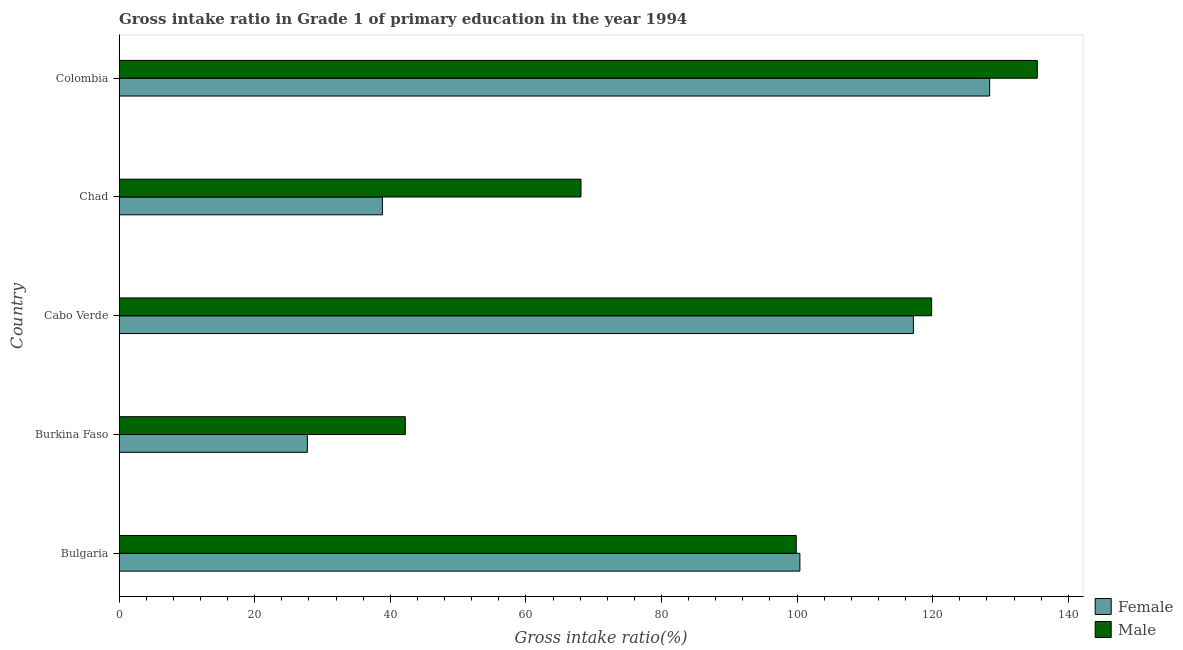How many different coloured bars are there?
Provide a short and direct response. 2. How many groups of bars are there?
Offer a very short reply. 5. What is the label of the 5th group of bars from the top?
Your answer should be compact. Bulgaria. What is the gross intake ratio(male) in Cabo Verde?
Keep it short and to the point. 119.84. Across all countries, what is the maximum gross intake ratio(female)?
Your answer should be compact. 128.4. Across all countries, what is the minimum gross intake ratio(male)?
Offer a very short reply. 42.22. In which country was the gross intake ratio(male) maximum?
Your response must be concise. Colombia. In which country was the gross intake ratio(female) minimum?
Ensure brevity in your answer.  Burkina Faso. What is the total gross intake ratio(female) in the graph?
Keep it short and to the point. 412.57. What is the difference between the gross intake ratio(male) in Chad and that in Colombia?
Offer a terse response. -67.3. What is the difference between the gross intake ratio(male) in Bulgaria and the gross intake ratio(female) in Chad?
Provide a short and direct response. 61.03. What is the average gross intake ratio(female) per country?
Keep it short and to the point. 82.51. What is the difference between the gross intake ratio(male) and gross intake ratio(female) in Burkina Faso?
Your response must be concise. 14.45. What is the ratio of the gross intake ratio(female) in Bulgaria to that in Cabo Verde?
Your response must be concise. 0.86. Is the difference between the gross intake ratio(male) in Bulgaria and Chad greater than the difference between the gross intake ratio(female) in Bulgaria and Chad?
Provide a short and direct response. No. What is the difference between the highest and the second highest gross intake ratio(male)?
Your answer should be compact. 15.58. What is the difference between the highest and the lowest gross intake ratio(female)?
Offer a very short reply. 100.62. What does the 2nd bar from the top in Cabo Verde represents?
Provide a succinct answer. Female. How many countries are there in the graph?
Offer a terse response. 5. What is the difference between two consecutive major ticks on the X-axis?
Your answer should be very brief. 20. Does the graph contain any zero values?
Your response must be concise. No. Where does the legend appear in the graph?
Your answer should be compact. Bottom right. How are the legend labels stacked?
Give a very brief answer. Vertical. What is the title of the graph?
Keep it short and to the point. Gross intake ratio in Grade 1 of primary education in the year 1994. Does "Females" appear as one of the legend labels in the graph?
Your response must be concise. No. What is the label or title of the X-axis?
Provide a succinct answer. Gross intake ratio(%). What is the label or title of the Y-axis?
Ensure brevity in your answer.  Country. What is the Gross intake ratio(%) in Female in Bulgaria?
Ensure brevity in your answer.  100.41. What is the Gross intake ratio(%) of Male in Bulgaria?
Provide a short and direct response. 99.87. What is the Gross intake ratio(%) of Female in Burkina Faso?
Provide a short and direct response. 27.77. What is the Gross intake ratio(%) in Male in Burkina Faso?
Ensure brevity in your answer.  42.22. What is the Gross intake ratio(%) in Female in Cabo Verde?
Your answer should be compact. 117.15. What is the Gross intake ratio(%) in Male in Cabo Verde?
Your answer should be compact. 119.84. What is the Gross intake ratio(%) of Female in Chad?
Provide a short and direct response. 38.84. What is the Gross intake ratio(%) of Male in Chad?
Make the answer very short. 68.13. What is the Gross intake ratio(%) of Female in Colombia?
Offer a very short reply. 128.4. What is the Gross intake ratio(%) in Male in Colombia?
Offer a very short reply. 135.42. Across all countries, what is the maximum Gross intake ratio(%) of Female?
Give a very brief answer. 128.4. Across all countries, what is the maximum Gross intake ratio(%) of Male?
Make the answer very short. 135.42. Across all countries, what is the minimum Gross intake ratio(%) of Female?
Make the answer very short. 27.77. Across all countries, what is the minimum Gross intake ratio(%) of Male?
Ensure brevity in your answer.  42.22. What is the total Gross intake ratio(%) in Female in the graph?
Give a very brief answer. 412.57. What is the total Gross intake ratio(%) of Male in the graph?
Offer a very short reply. 465.48. What is the difference between the Gross intake ratio(%) in Female in Bulgaria and that in Burkina Faso?
Your answer should be very brief. 72.64. What is the difference between the Gross intake ratio(%) of Male in Bulgaria and that in Burkina Faso?
Provide a succinct answer. 57.65. What is the difference between the Gross intake ratio(%) of Female in Bulgaria and that in Cabo Verde?
Your response must be concise. -16.74. What is the difference between the Gross intake ratio(%) in Male in Bulgaria and that in Cabo Verde?
Provide a short and direct response. -19.97. What is the difference between the Gross intake ratio(%) in Female in Bulgaria and that in Chad?
Offer a terse response. 61.57. What is the difference between the Gross intake ratio(%) of Male in Bulgaria and that in Chad?
Provide a short and direct response. 31.75. What is the difference between the Gross intake ratio(%) in Female in Bulgaria and that in Colombia?
Your answer should be compact. -27.99. What is the difference between the Gross intake ratio(%) of Male in Bulgaria and that in Colombia?
Offer a terse response. -35.55. What is the difference between the Gross intake ratio(%) of Female in Burkina Faso and that in Cabo Verde?
Give a very brief answer. -89.38. What is the difference between the Gross intake ratio(%) in Male in Burkina Faso and that in Cabo Verde?
Your answer should be compact. -77.63. What is the difference between the Gross intake ratio(%) of Female in Burkina Faso and that in Chad?
Offer a very short reply. -11.07. What is the difference between the Gross intake ratio(%) of Male in Burkina Faso and that in Chad?
Provide a short and direct response. -25.91. What is the difference between the Gross intake ratio(%) in Female in Burkina Faso and that in Colombia?
Provide a short and direct response. -100.62. What is the difference between the Gross intake ratio(%) of Male in Burkina Faso and that in Colombia?
Your response must be concise. -93.2. What is the difference between the Gross intake ratio(%) of Female in Cabo Verde and that in Chad?
Offer a terse response. 78.31. What is the difference between the Gross intake ratio(%) of Male in Cabo Verde and that in Chad?
Your response must be concise. 51.72. What is the difference between the Gross intake ratio(%) in Female in Cabo Verde and that in Colombia?
Provide a short and direct response. -11.25. What is the difference between the Gross intake ratio(%) of Male in Cabo Verde and that in Colombia?
Give a very brief answer. -15.58. What is the difference between the Gross intake ratio(%) of Female in Chad and that in Colombia?
Offer a very short reply. -89.56. What is the difference between the Gross intake ratio(%) of Male in Chad and that in Colombia?
Provide a succinct answer. -67.3. What is the difference between the Gross intake ratio(%) in Female in Bulgaria and the Gross intake ratio(%) in Male in Burkina Faso?
Offer a very short reply. 58.19. What is the difference between the Gross intake ratio(%) in Female in Bulgaria and the Gross intake ratio(%) in Male in Cabo Verde?
Make the answer very short. -19.43. What is the difference between the Gross intake ratio(%) in Female in Bulgaria and the Gross intake ratio(%) in Male in Chad?
Offer a very short reply. 32.28. What is the difference between the Gross intake ratio(%) of Female in Bulgaria and the Gross intake ratio(%) of Male in Colombia?
Offer a very short reply. -35.01. What is the difference between the Gross intake ratio(%) of Female in Burkina Faso and the Gross intake ratio(%) of Male in Cabo Verde?
Provide a short and direct response. -92.07. What is the difference between the Gross intake ratio(%) in Female in Burkina Faso and the Gross intake ratio(%) in Male in Chad?
Your response must be concise. -40.35. What is the difference between the Gross intake ratio(%) in Female in Burkina Faso and the Gross intake ratio(%) in Male in Colombia?
Provide a short and direct response. -107.65. What is the difference between the Gross intake ratio(%) of Female in Cabo Verde and the Gross intake ratio(%) of Male in Chad?
Give a very brief answer. 49.02. What is the difference between the Gross intake ratio(%) of Female in Cabo Verde and the Gross intake ratio(%) of Male in Colombia?
Provide a short and direct response. -18.27. What is the difference between the Gross intake ratio(%) in Female in Chad and the Gross intake ratio(%) in Male in Colombia?
Your answer should be compact. -96.58. What is the average Gross intake ratio(%) of Female per country?
Give a very brief answer. 82.51. What is the average Gross intake ratio(%) of Male per country?
Make the answer very short. 93.1. What is the difference between the Gross intake ratio(%) in Female and Gross intake ratio(%) in Male in Bulgaria?
Make the answer very short. 0.54. What is the difference between the Gross intake ratio(%) of Female and Gross intake ratio(%) of Male in Burkina Faso?
Provide a short and direct response. -14.45. What is the difference between the Gross intake ratio(%) of Female and Gross intake ratio(%) of Male in Cabo Verde?
Your answer should be compact. -2.69. What is the difference between the Gross intake ratio(%) in Female and Gross intake ratio(%) in Male in Chad?
Your answer should be compact. -29.29. What is the difference between the Gross intake ratio(%) in Female and Gross intake ratio(%) in Male in Colombia?
Provide a short and direct response. -7.03. What is the ratio of the Gross intake ratio(%) of Female in Bulgaria to that in Burkina Faso?
Provide a short and direct response. 3.62. What is the ratio of the Gross intake ratio(%) in Male in Bulgaria to that in Burkina Faso?
Provide a succinct answer. 2.37. What is the ratio of the Gross intake ratio(%) of Female in Bulgaria to that in Cabo Verde?
Your answer should be very brief. 0.86. What is the ratio of the Gross intake ratio(%) of Male in Bulgaria to that in Cabo Verde?
Ensure brevity in your answer.  0.83. What is the ratio of the Gross intake ratio(%) of Female in Bulgaria to that in Chad?
Keep it short and to the point. 2.59. What is the ratio of the Gross intake ratio(%) of Male in Bulgaria to that in Chad?
Offer a terse response. 1.47. What is the ratio of the Gross intake ratio(%) in Female in Bulgaria to that in Colombia?
Give a very brief answer. 0.78. What is the ratio of the Gross intake ratio(%) of Male in Bulgaria to that in Colombia?
Provide a succinct answer. 0.74. What is the ratio of the Gross intake ratio(%) of Female in Burkina Faso to that in Cabo Verde?
Provide a short and direct response. 0.24. What is the ratio of the Gross intake ratio(%) in Male in Burkina Faso to that in Cabo Verde?
Provide a succinct answer. 0.35. What is the ratio of the Gross intake ratio(%) in Female in Burkina Faso to that in Chad?
Your response must be concise. 0.71. What is the ratio of the Gross intake ratio(%) in Male in Burkina Faso to that in Chad?
Keep it short and to the point. 0.62. What is the ratio of the Gross intake ratio(%) in Female in Burkina Faso to that in Colombia?
Keep it short and to the point. 0.22. What is the ratio of the Gross intake ratio(%) of Male in Burkina Faso to that in Colombia?
Your answer should be compact. 0.31. What is the ratio of the Gross intake ratio(%) of Female in Cabo Verde to that in Chad?
Give a very brief answer. 3.02. What is the ratio of the Gross intake ratio(%) in Male in Cabo Verde to that in Chad?
Offer a terse response. 1.76. What is the ratio of the Gross intake ratio(%) in Female in Cabo Verde to that in Colombia?
Make the answer very short. 0.91. What is the ratio of the Gross intake ratio(%) in Male in Cabo Verde to that in Colombia?
Provide a short and direct response. 0.89. What is the ratio of the Gross intake ratio(%) of Female in Chad to that in Colombia?
Offer a terse response. 0.3. What is the ratio of the Gross intake ratio(%) in Male in Chad to that in Colombia?
Keep it short and to the point. 0.5. What is the difference between the highest and the second highest Gross intake ratio(%) of Female?
Offer a very short reply. 11.25. What is the difference between the highest and the second highest Gross intake ratio(%) in Male?
Your response must be concise. 15.58. What is the difference between the highest and the lowest Gross intake ratio(%) in Female?
Keep it short and to the point. 100.62. What is the difference between the highest and the lowest Gross intake ratio(%) in Male?
Your answer should be very brief. 93.2. 